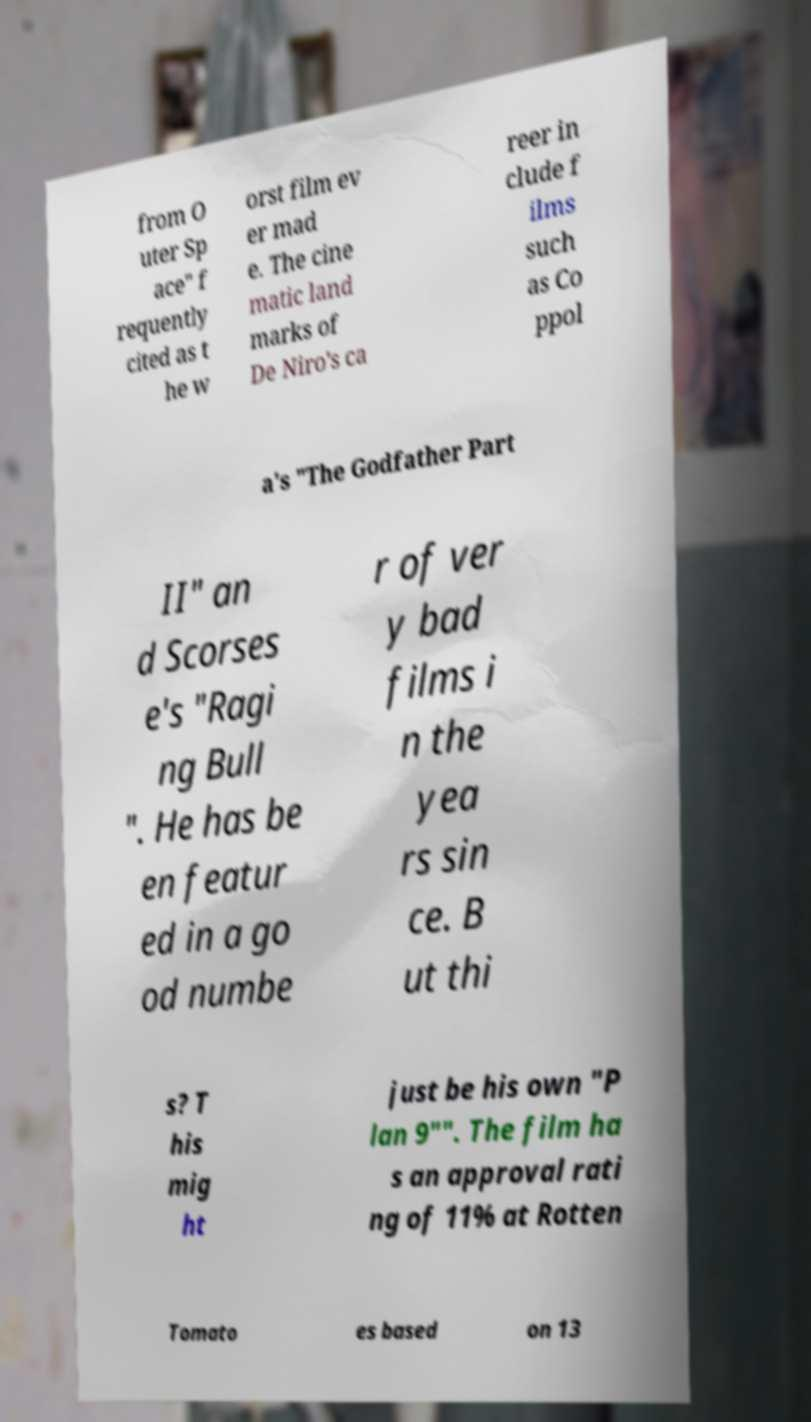For documentation purposes, I need the text within this image transcribed. Could you provide that? from O uter Sp ace" f requently cited as t he w orst film ev er mad e. The cine matic land marks of De Niro's ca reer in clude f ilms such as Co ppol a's "The Godfather Part II" an d Scorses e's "Ragi ng Bull ". He has be en featur ed in a go od numbe r of ver y bad films i n the yea rs sin ce. B ut thi s? T his mig ht just be his own "P lan 9"". The film ha s an approval rati ng of 11% at Rotten Tomato es based on 13 